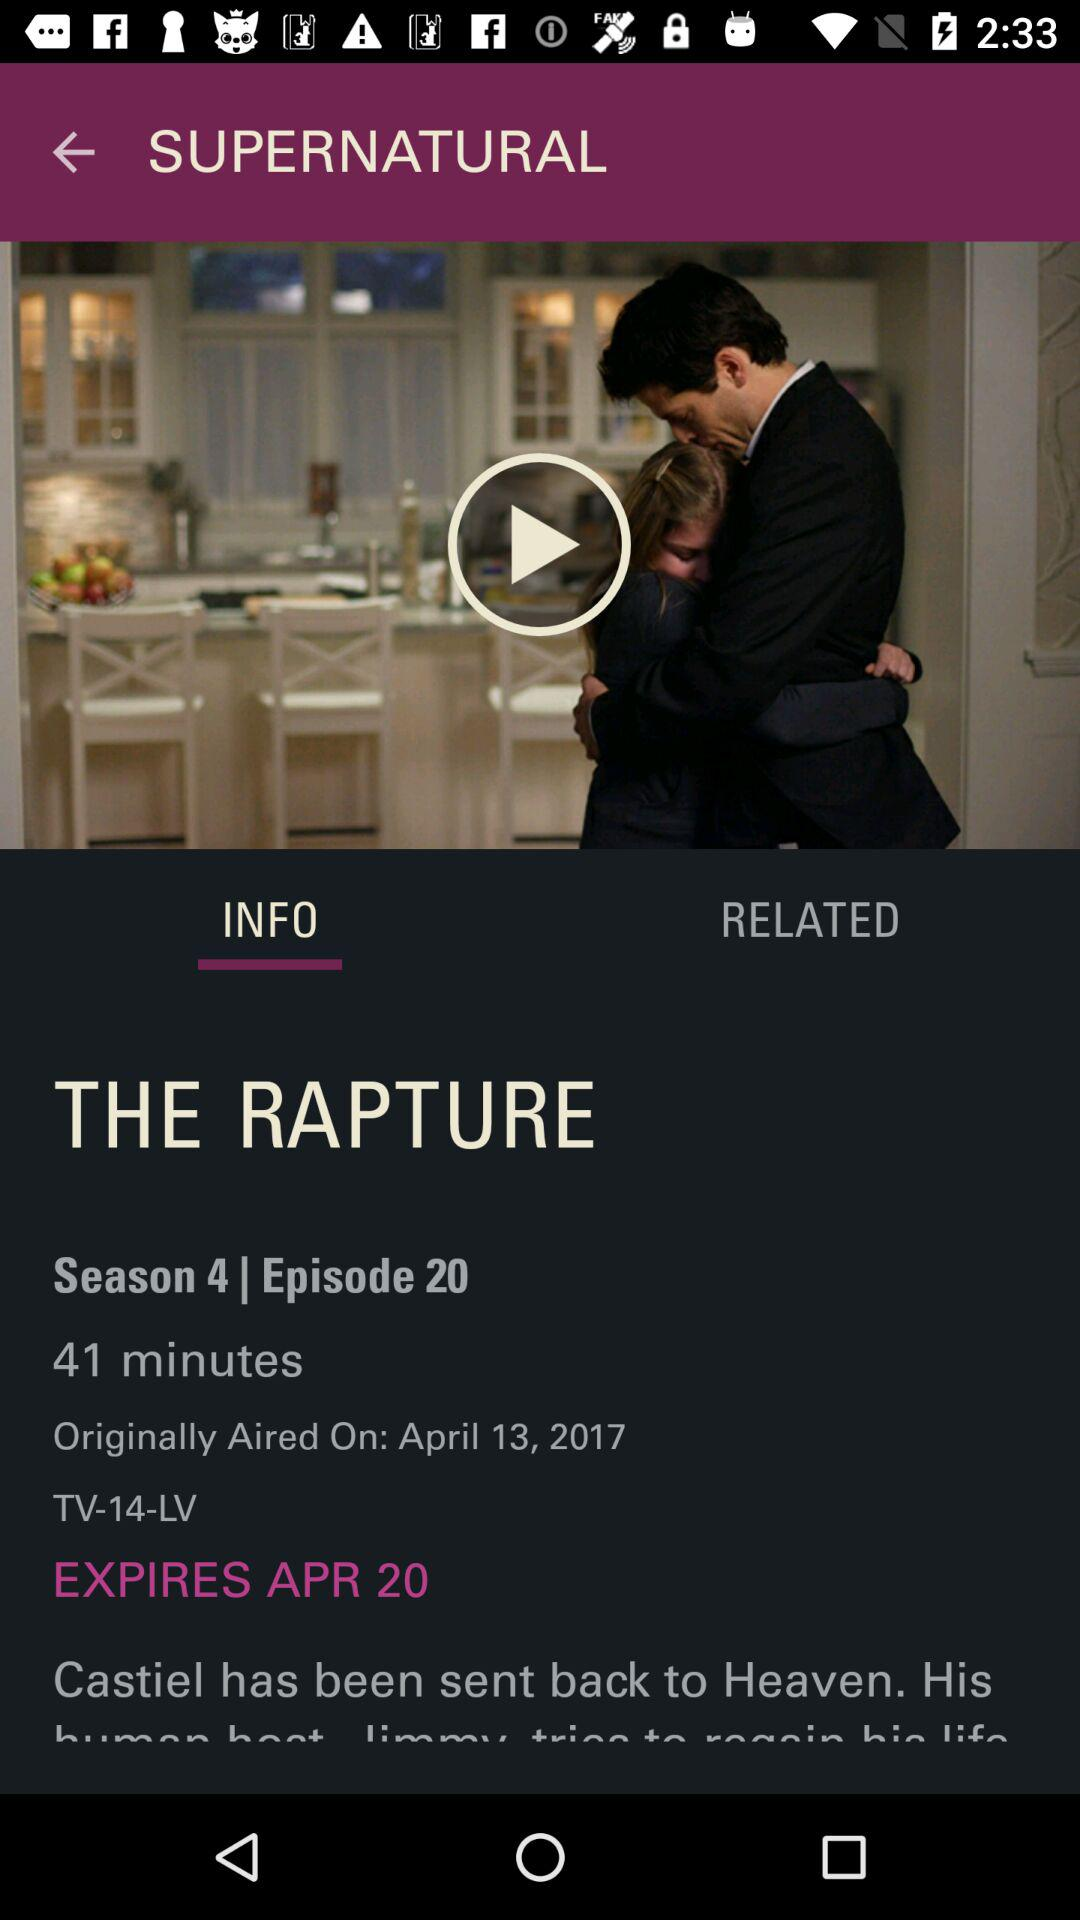Which tab is selected? The selected tab is "INFO". 